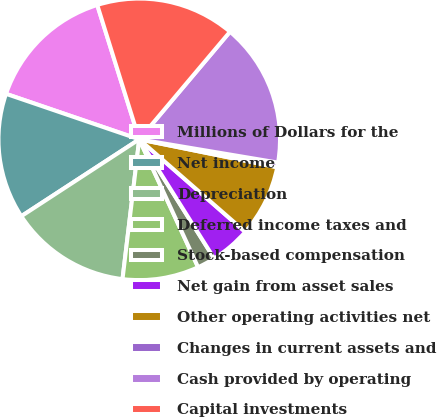Convert chart. <chart><loc_0><loc_0><loc_500><loc_500><pie_chart><fcel>Millions of Dollars for the<fcel>Net income<fcel>Depreciation<fcel>Deferred income taxes and<fcel>Stock-based compensation<fcel>Net gain from asset sales<fcel>Other operating activities net<fcel>Changes in current assets and<fcel>Cash provided by operating<fcel>Capital investments<nl><fcel>14.94%<fcel>14.43%<fcel>13.91%<fcel>8.76%<fcel>2.07%<fcel>4.64%<fcel>8.25%<fcel>0.53%<fcel>16.49%<fcel>15.97%<nl></chart> 